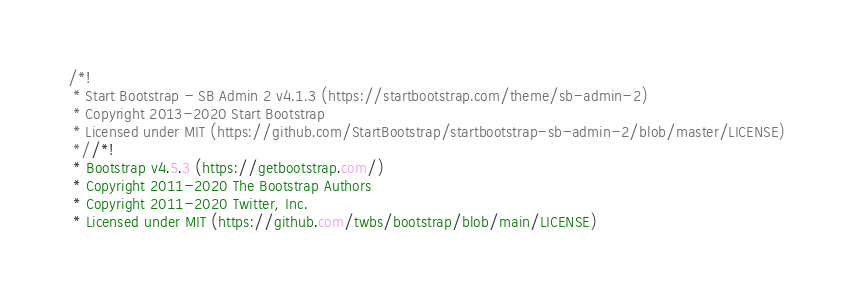<code> <loc_0><loc_0><loc_500><loc_500><_CSS_>/*!
 * Start Bootstrap - SB Admin 2 v4.1.3 (https://startbootstrap.com/theme/sb-admin-2)
 * Copyright 2013-2020 Start Bootstrap
 * Licensed under MIT (https://github.com/StartBootstrap/startbootstrap-sb-admin-2/blob/master/LICENSE)
 *//*!
 * Bootstrap v4.5.3 (https://getbootstrap.com/)
 * Copyright 2011-2020 The Bootstrap Authors
 * Copyright 2011-2020 Twitter, Inc.
 * Licensed under MIT (https://github.com/twbs/bootstrap/blob/main/LICENSE)</code> 